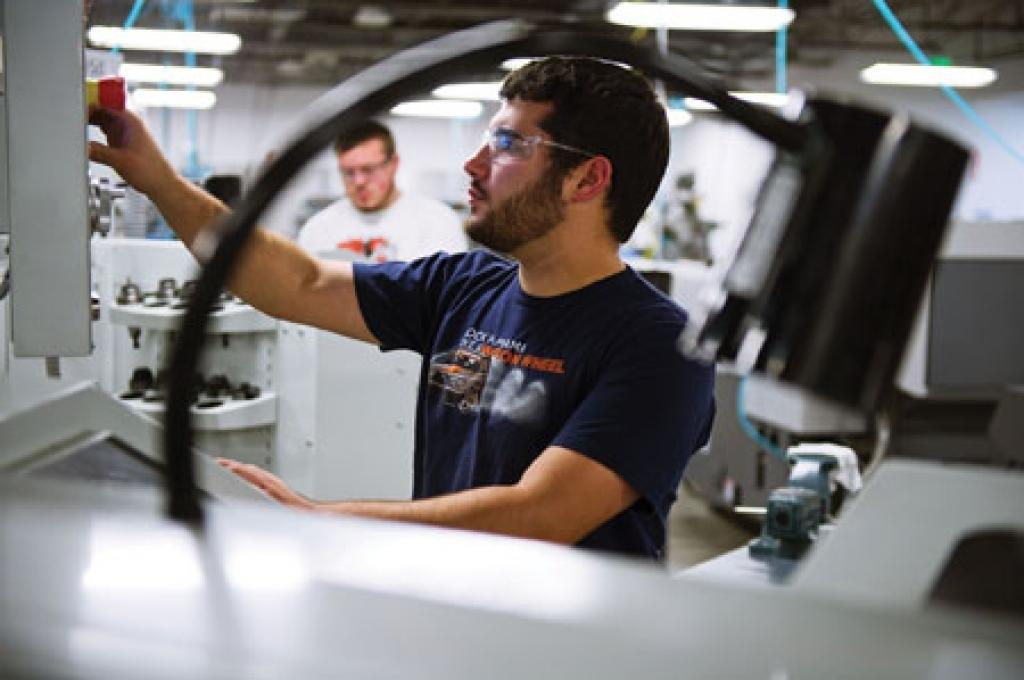What is the man in the image doing? The man is operating a machine in the image. How is the man operating the machine? The man is using his hand to operate the machine. Can you describe the man's appearance? The man is wearing spectacles. Is there anyone else in the image? Yes, there is another man standing nearby in the image. What can be seen in terms of lighting in the image? There are lights visible in the image. Where is the playground located in the image? There is no playground present in the image. What type of sponge is being used by the man to operate the machine? The man is using his hand, not a sponge, to operate the machine. 